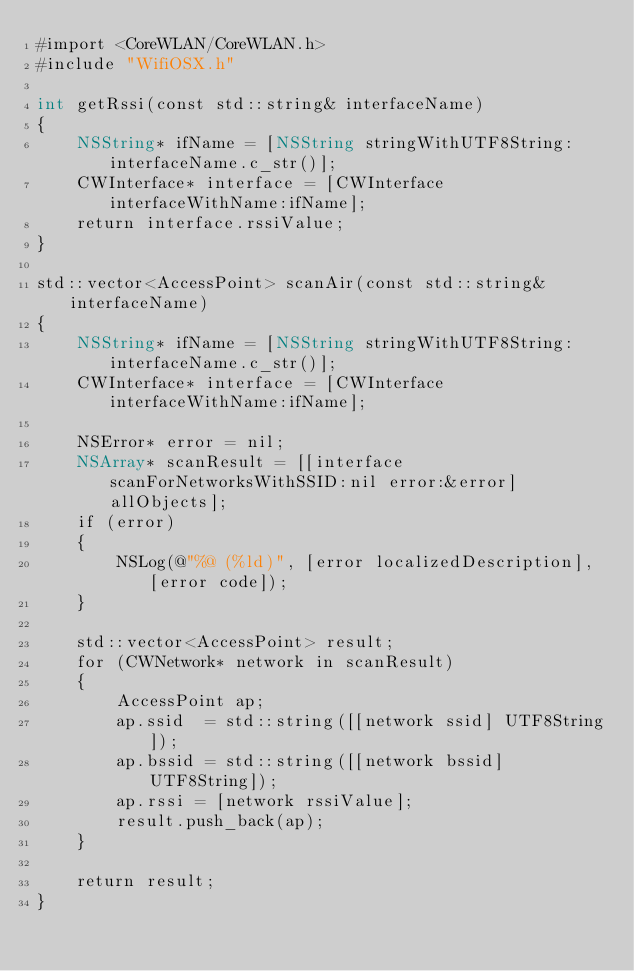Convert code to text. <code><loc_0><loc_0><loc_500><loc_500><_ObjectiveC_>#import <CoreWLAN/CoreWLAN.h>
#include "WifiOSX.h"

int getRssi(const std::string& interfaceName)
{
    NSString* ifName = [NSString stringWithUTF8String:interfaceName.c_str()];
    CWInterface* interface = [CWInterface interfaceWithName:ifName];
    return interface.rssiValue;
}

std::vector<AccessPoint> scanAir(const std::string& interfaceName)
{
    NSString* ifName = [NSString stringWithUTF8String:interfaceName.c_str()];
    CWInterface* interface = [CWInterface interfaceWithName:ifName];
    
    NSError* error = nil;
    NSArray* scanResult = [[interface scanForNetworksWithSSID:nil error:&error] allObjects];
    if (error)
    {
        NSLog(@"%@ (%ld)", [error localizedDescription], [error code]);
    }
    
    std::vector<AccessPoint> result;
    for (CWNetwork* network in scanResult)
    {
        AccessPoint ap;
        ap.ssid  = std::string([[network ssid] UTF8String]);
        ap.bssid = std::string([[network bssid] UTF8String]);
        ap.rssi = [network rssiValue];
        result.push_back(ap);
    }
    
    return result;
}</code> 